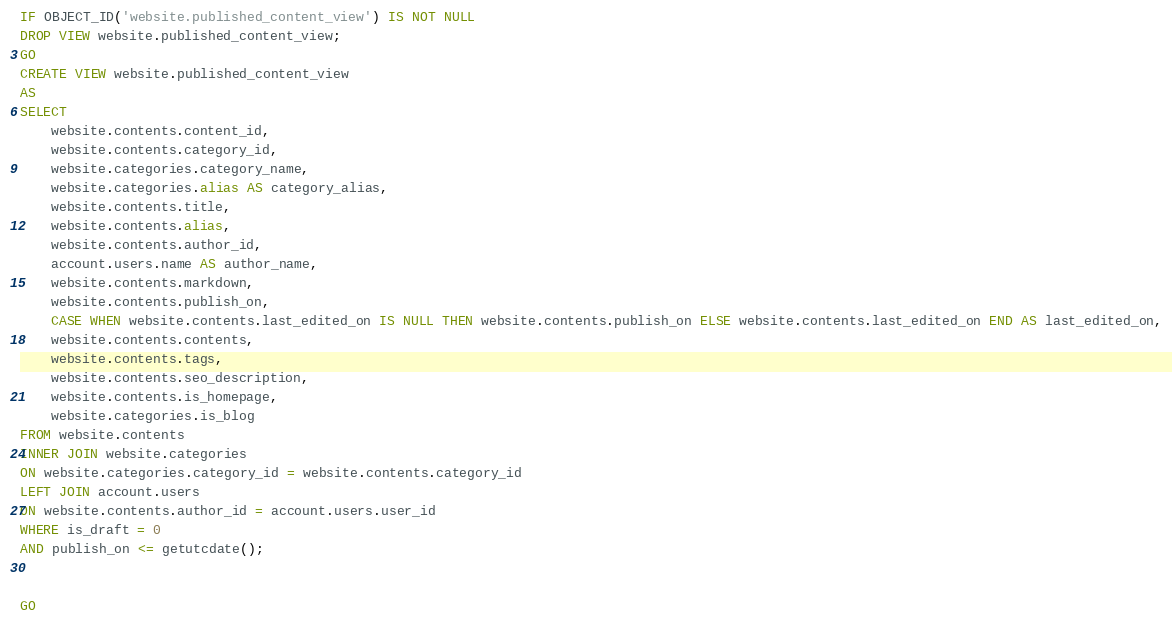<code> <loc_0><loc_0><loc_500><loc_500><_SQL_>IF OBJECT_ID('website.published_content_view') IS NOT NULL
DROP VIEW website.published_content_view;
GO
CREATE VIEW website.published_content_view
AS
SELECT
    website.contents.content_id,
    website.contents.category_id,
    website.categories.category_name,
    website.categories.alias AS category_alias,
    website.contents.title,
    website.contents.alias,
    website.contents.author_id,
    account.users.name AS author_name,
    website.contents.markdown,
    website.contents.publish_on,
    CASE WHEN website.contents.last_edited_on IS NULL THEN website.contents.publish_on ELSE website.contents.last_edited_on END AS last_edited_on,
    website.contents.contents,
    website.contents.tags,
    website.contents.seo_description,
    website.contents.is_homepage,
    website.categories.is_blog
FROM website.contents
INNER JOIN website.categories
ON website.categories.category_id = website.contents.category_id
LEFT JOIN account.users
ON website.contents.author_id = account.users.user_id
WHERE is_draft = 0
AND publish_on <= getutcdate();


GO
</code> 